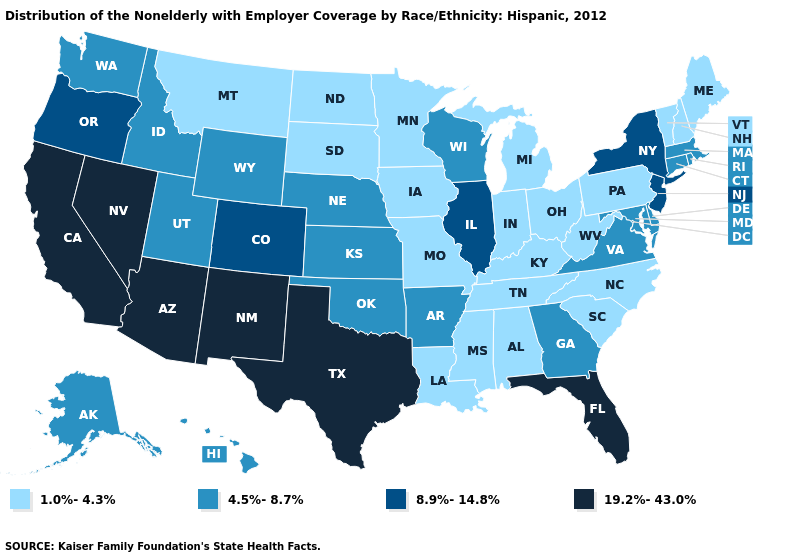How many symbols are there in the legend?
Give a very brief answer. 4. Among the states that border Kansas , does Missouri have the highest value?
Write a very short answer. No. Is the legend a continuous bar?
Keep it brief. No. What is the lowest value in the USA?
Answer briefly. 1.0%-4.3%. Does the first symbol in the legend represent the smallest category?
Write a very short answer. Yes. What is the value of Massachusetts?
Concise answer only. 4.5%-8.7%. Name the states that have a value in the range 1.0%-4.3%?
Keep it brief. Alabama, Indiana, Iowa, Kentucky, Louisiana, Maine, Michigan, Minnesota, Mississippi, Missouri, Montana, New Hampshire, North Carolina, North Dakota, Ohio, Pennsylvania, South Carolina, South Dakota, Tennessee, Vermont, West Virginia. Among the states that border Tennessee , which have the lowest value?
Give a very brief answer. Alabama, Kentucky, Mississippi, Missouri, North Carolina. Name the states that have a value in the range 8.9%-14.8%?
Answer briefly. Colorado, Illinois, New Jersey, New York, Oregon. Does South Dakota have a lower value than Iowa?
Write a very short answer. No. Which states have the lowest value in the MidWest?
Give a very brief answer. Indiana, Iowa, Michigan, Minnesota, Missouri, North Dakota, Ohio, South Dakota. Among the states that border Colorado , which have the highest value?
Answer briefly. Arizona, New Mexico. Which states have the lowest value in the South?
Quick response, please. Alabama, Kentucky, Louisiana, Mississippi, North Carolina, South Carolina, Tennessee, West Virginia. Among the states that border California , does Oregon have the lowest value?
Give a very brief answer. Yes. 